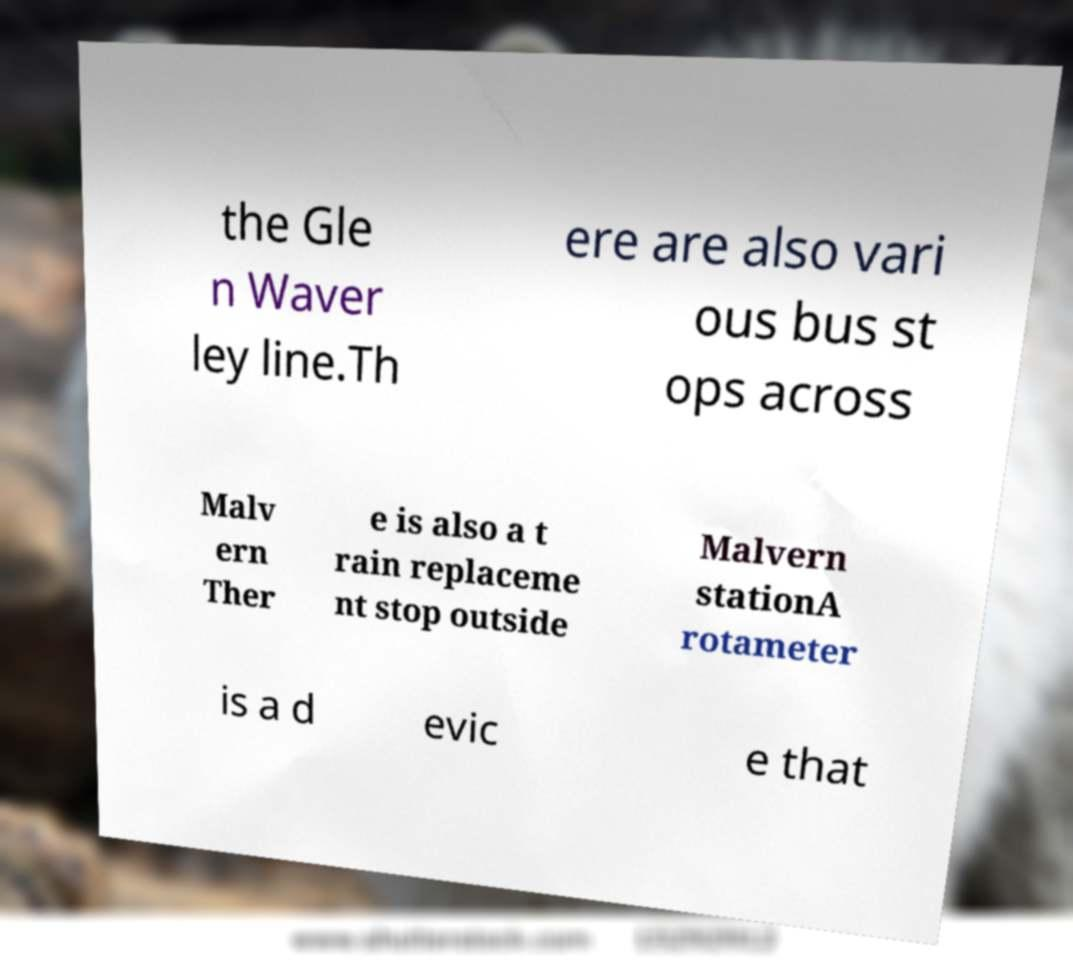Can you read and provide the text displayed in the image?This photo seems to have some interesting text. Can you extract and type it out for me? the Gle n Waver ley line.Th ere are also vari ous bus st ops across Malv ern Ther e is also a t rain replaceme nt stop outside Malvern stationA rotameter is a d evic e that 